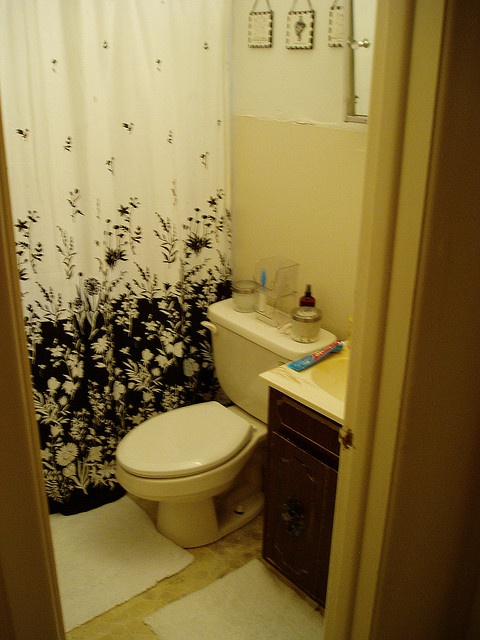Describe the objects in this image and their specific colors. I can see toilet in tan and olive tones, sink in tan, khaki, and gold tones, bottle in tan and olive tones, toothbrush in tan, khaki, and olive tones, and toothbrush in tan, gray, teal, and olive tones in this image. 